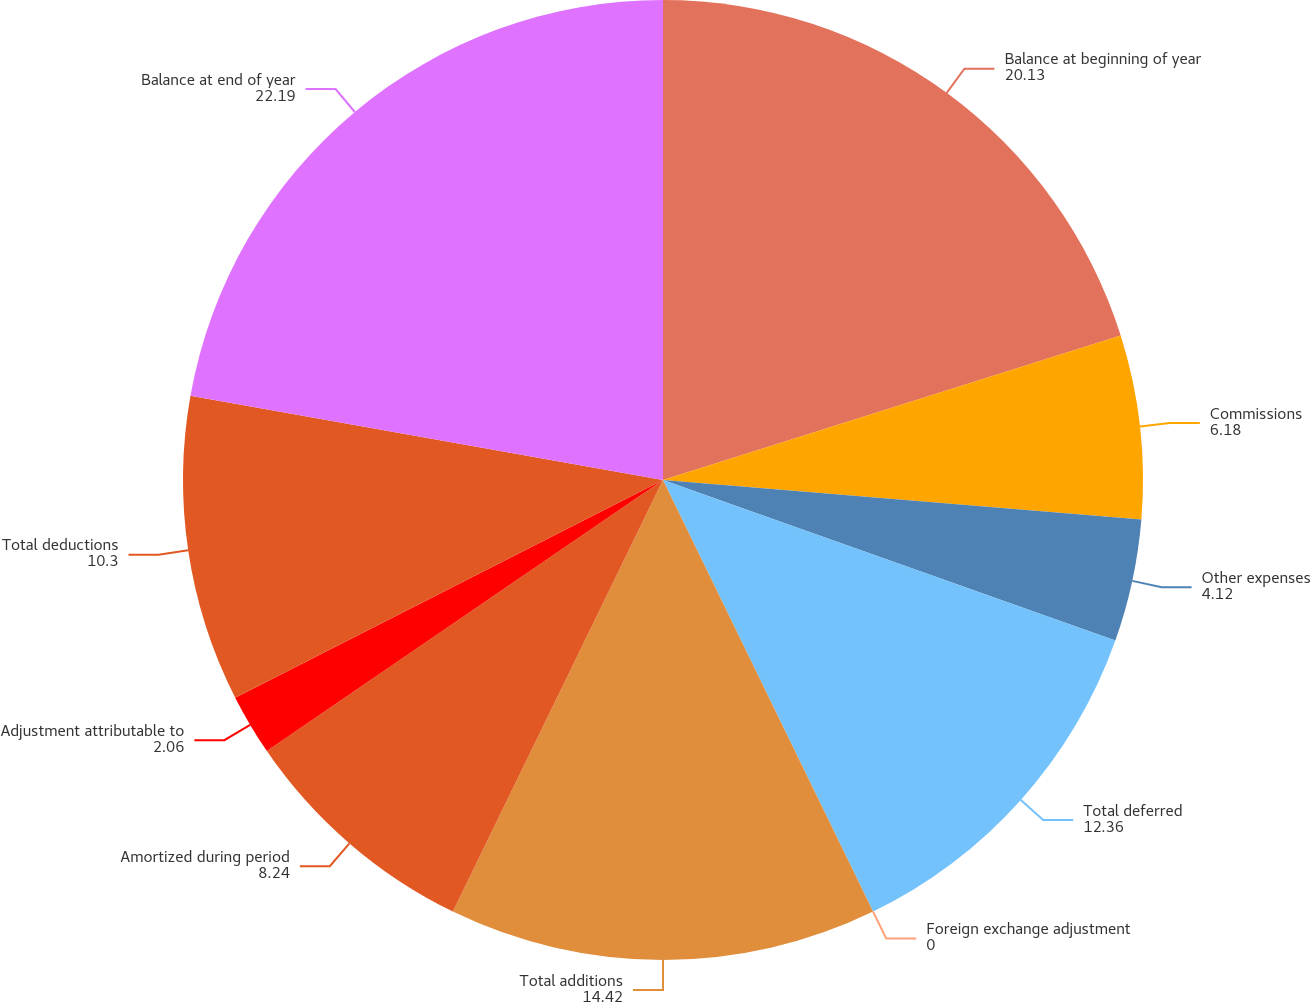<chart> <loc_0><loc_0><loc_500><loc_500><pie_chart><fcel>Balance at beginning of year<fcel>Commissions<fcel>Other expenses<fcel>Total deferred<fcel>Foreign exchange adjustment<fcel>Total additions<fcel>Amortized during period<fcel>Adjustment attributable to<fcel>Total deductions<fcel>Balance at end of year<nl><fcel>20.13%<fcel>6.18%<fcel>4.12%<fcel>12.36%<fcel>0.0%<fcel>14.42%<fcel>8.24%<fcel>2.06%<fcel>10.3%<fcel>22.19%<nl></chart> 